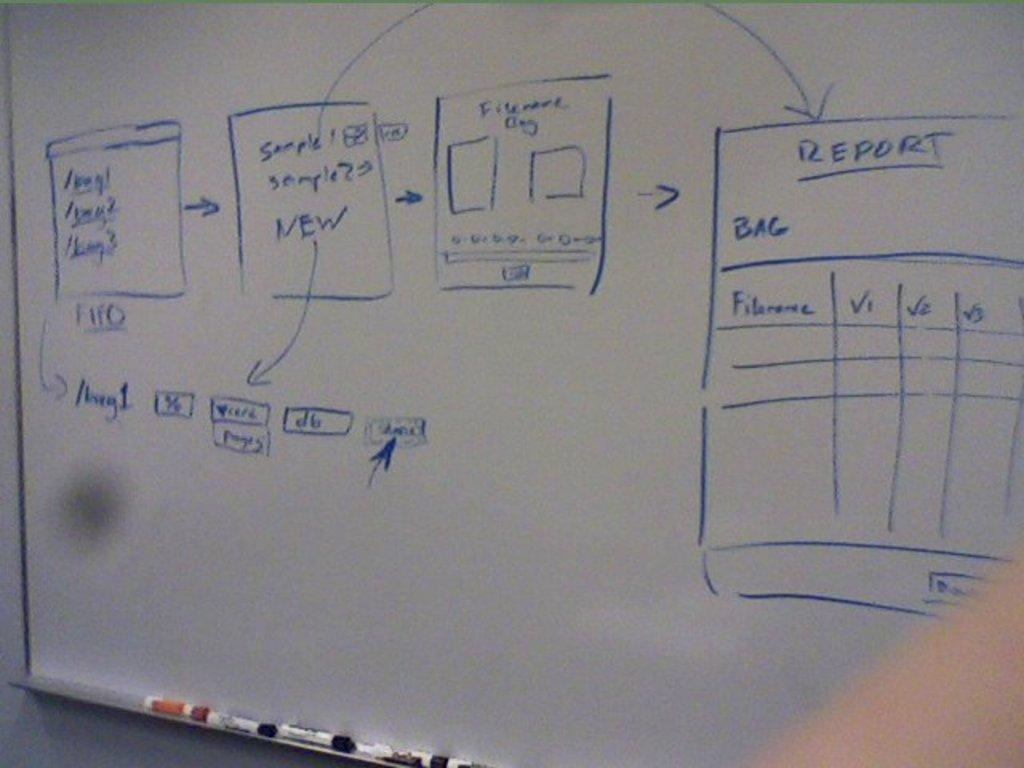<image>
Share a concise interpretation of the image provided. Blue marker on a white board show with a report box that has file name, and V1, V2, and V3. 